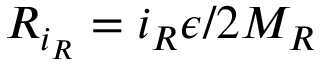<formula> <loc_0><loc_0><loc_500><loc_500>R _ { i _ { R } } = i _ { R } \epsilon / 2 M _ { R }</formula> 